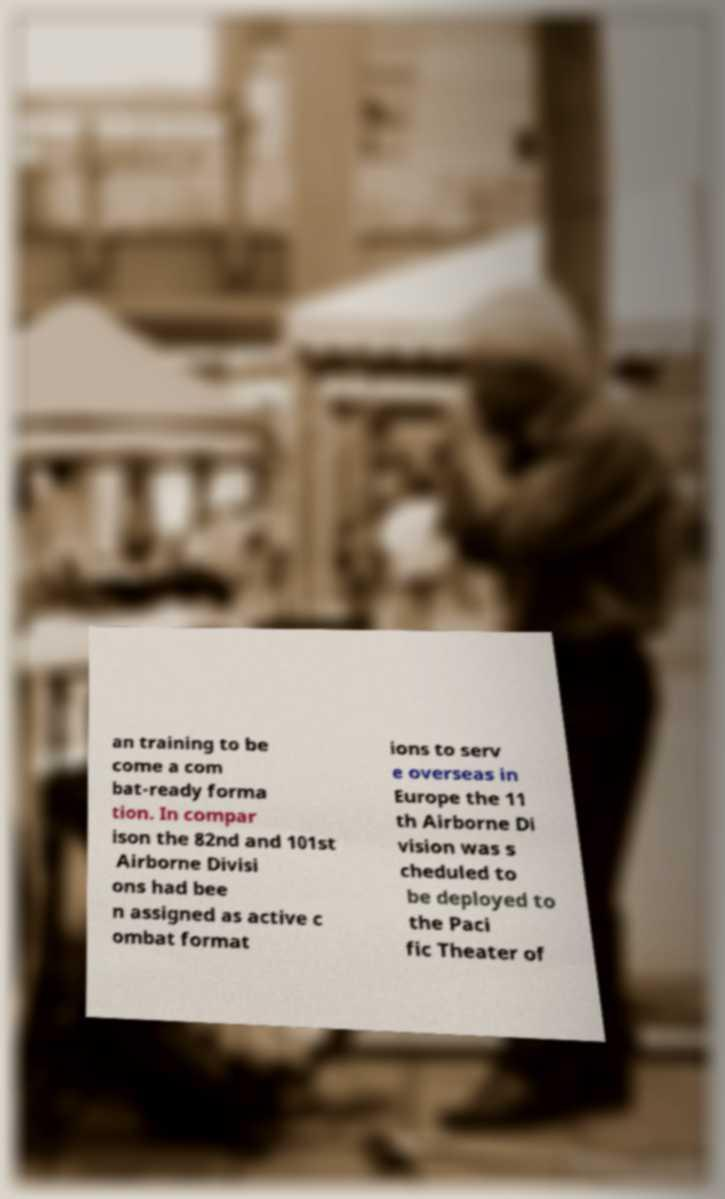I need the written content from this picture converted into text. Can you do that? an training to be come a com bat-ready forma tion. In compar ison the 82nd and 101st Airborne Divisi ons had bee n assigned as active c ombat format ions to serv e overseas in Europe the 11 th Airborne Di vision was s cheduled to be deployed to the Paci fic Theater of 